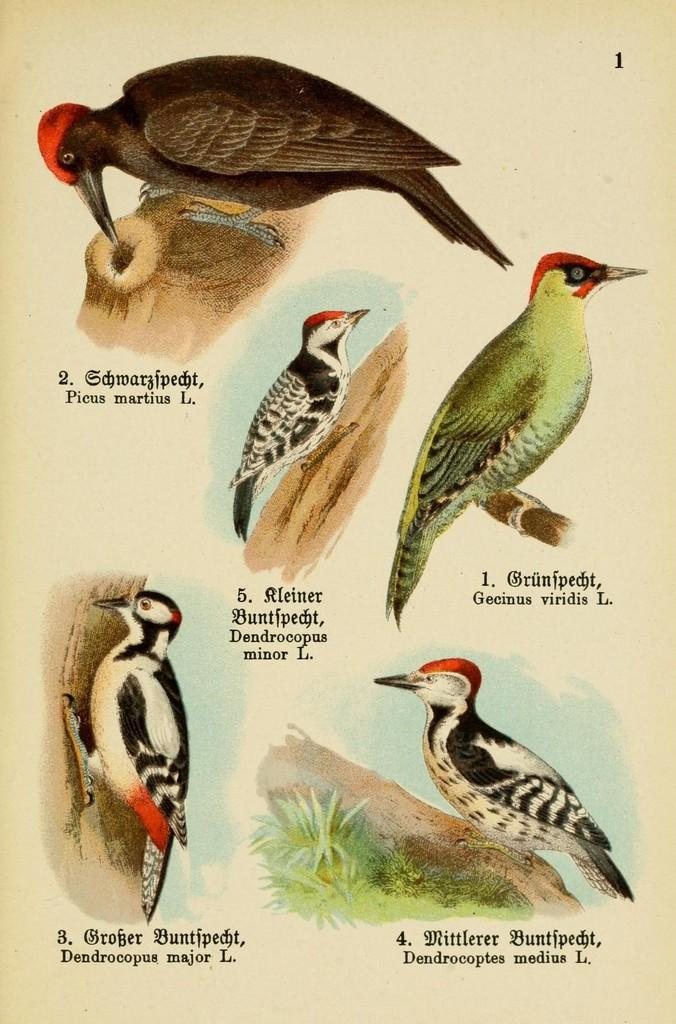What is featured in the image? There is a poster in the image. What is the subject matter of the poster? The poster contains different types of birds. How are the birds positioned on the poster? The birds are depicted on the branches of trees. What type of stem can be seen growing from the poster in the image? There is no stem present in the image; it features a poster with birds depicted on tree branches. 